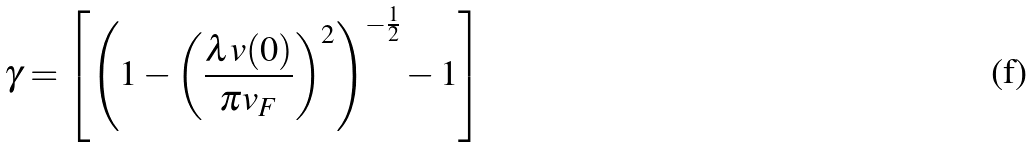<formula> <loc_0><loc_0><loc_500><loc_500>\gamma = \left [ \left ( 1 - \left ( \frac { \lambda v ( 0 ) } { \pi v _ { F } } \right ) ^ { 2 } \right ) ^ { - \frac { 1 } { 2 } } - 1 \right ]</formula> 